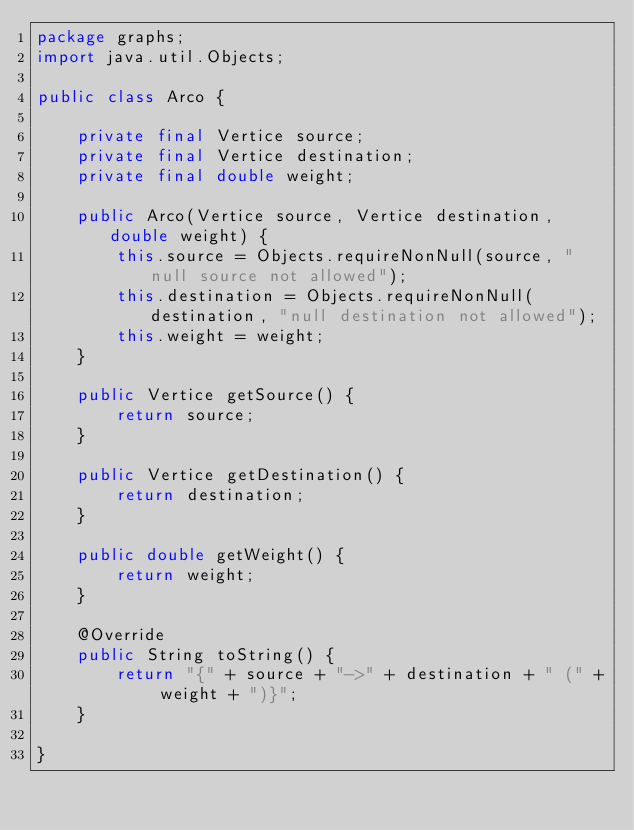Convert code to text. <code><loc_0><loc_0><loc_500><loc_500><_Java_>package graphs;
import java.util.Objects;

public class Arco {

    private final Vertice source;
    private final Vertice destination;
    private final double weight;

    public Arco(Vertice source, Vertice destination, double weight) {
        this.source = Objects.requireNonNull(source, "null source not allowed");
        this.destination = Objects.requireNonNull(destination, "null destination not allowed");
        this.weight = weight;
    }

    public Vertice getSource() {
        return source;
    }

    public Vertice getDestination() {
        return destination;
    }

    public double getWeight() {
        return weight;
    }

    @Override
    public String toString() {
        return "{" + source + "->" + destination + " (" + weight + ")}";
    }

}
</code> 